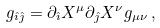Convert formula to latex. <formula><loc_0><loc_0><loc_500><loc_500>g _ { \hat { \imath } \hat { \jmath } } = \partial _ { \hat { \imath } } X ^ { \mu } \partial _ { \hat { \jmath } } X ^ { \nu } g _ { \mu \nu } \, ,</formula> 